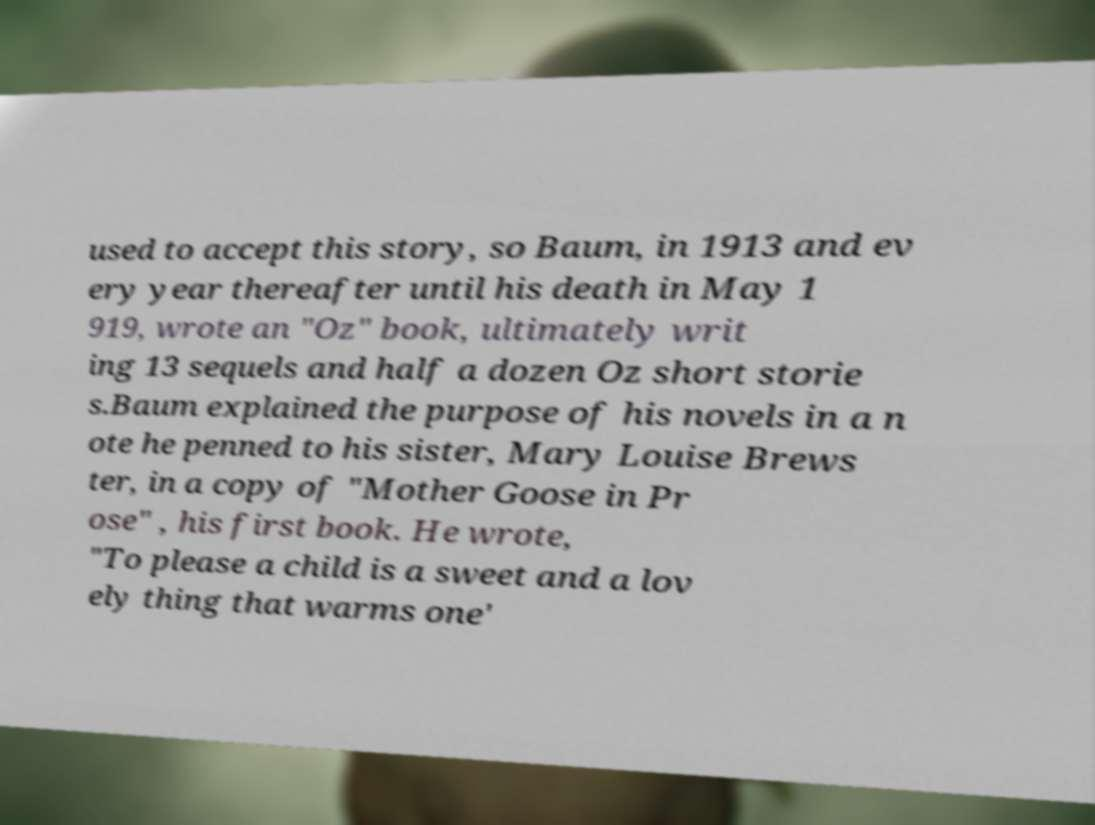Please read and relay the text visible in this image. What does it say? used to accept this story, so Baum, in 1913 and ev ery year thereafter until his death in May 1 919, wrote an "Oz" book, ultimately writ ing 13 sequels and half a dozen Oz short storie s.Baum explained the purpose of his novels in a n ote he penned to his sister, Mary Louise Brews ter, in a copy of "Mother Goose in Pr ose" , his first book. He wrote, "To please a child is a sweet and a lov ely thing that warms one' 